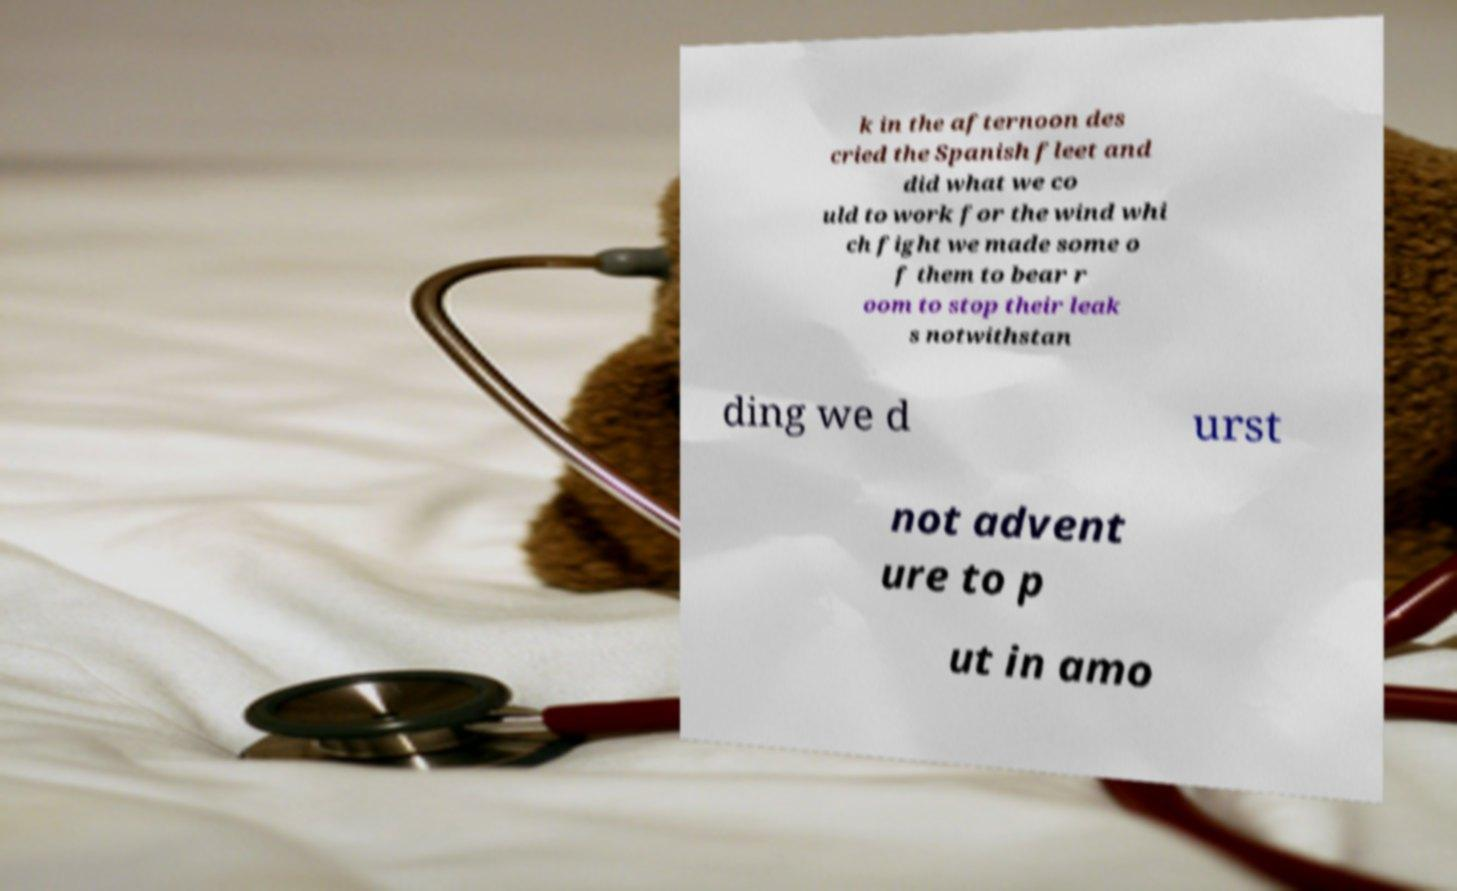Please read and relay the text visible in this image. What does it say? k in the afternoon des cried the Spanish fleet and did what we co uld to work for the wind whi ch fight we made some o f them to bear r oom to stop their leak s notwithstan ding we d urst not advent ure to p ut in amo 